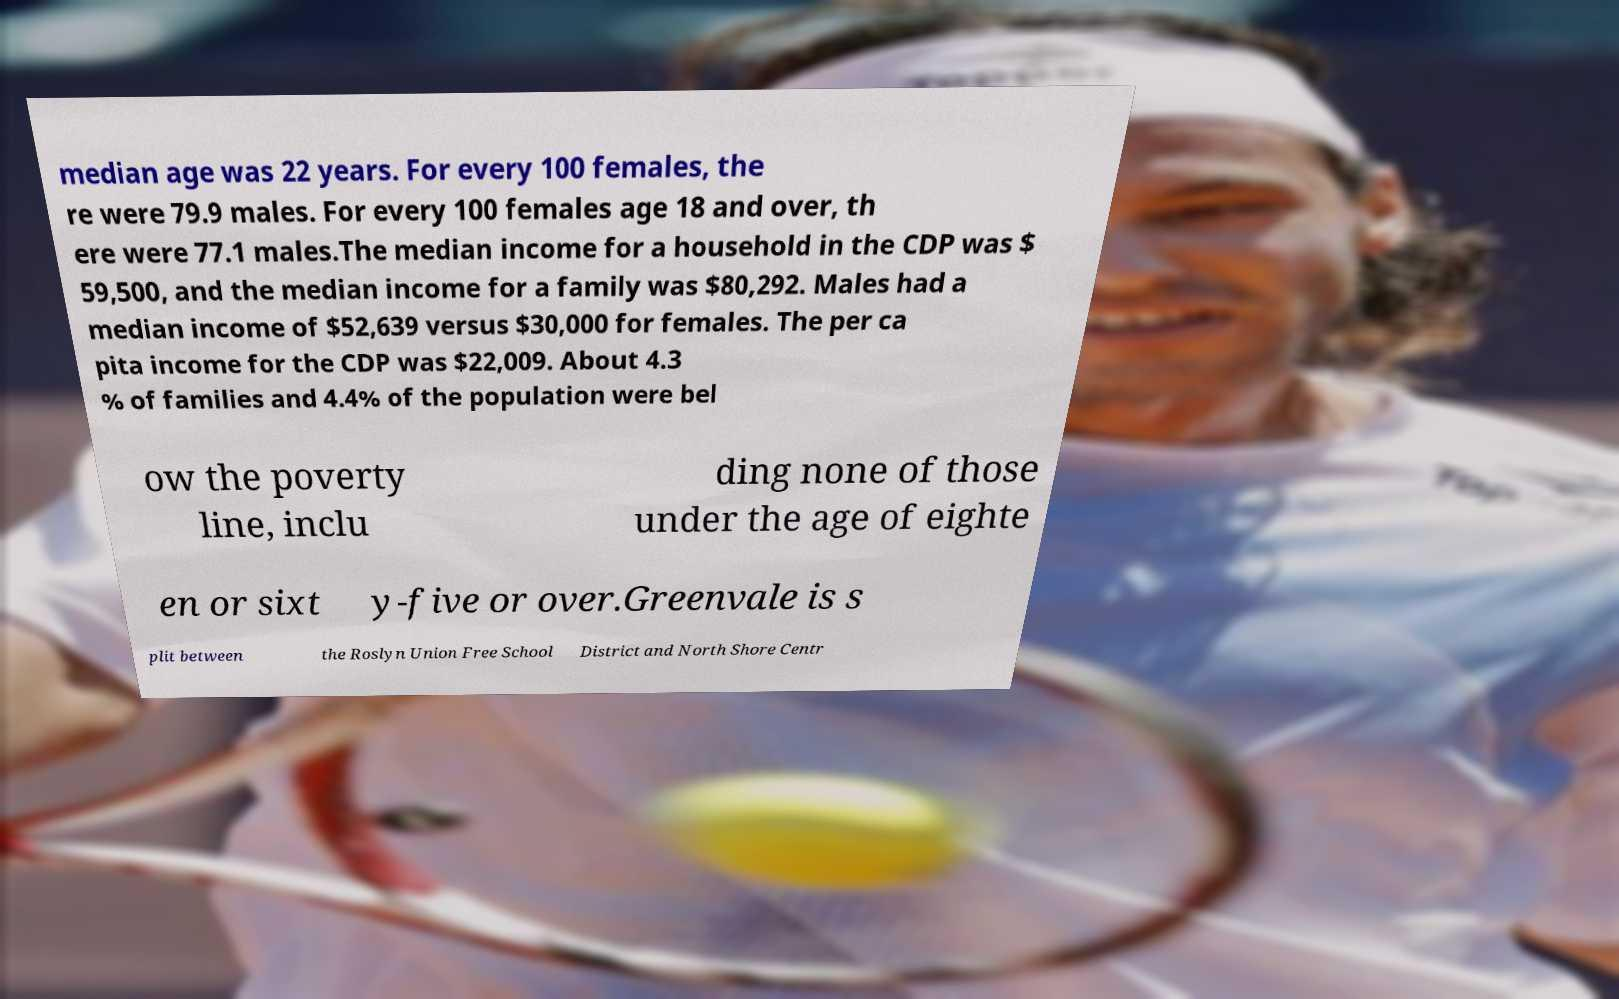Could you extract and type out the text from this image? median age was 22 years. For every 100 females, the re were 79.9 males. For every 100 females age 18 and over, th ere were 77.1 males.The median income for a household in the CDP was $ 59,500, and the median income for a family was $80,292. Males had a median income of $52,639 versus $30,000 for females. The per ca pita income for the CDP was $22,009. About 4.3 % of families and 4.4% of the population were bel ow the poverty line, inclu ding none of those under the age of eighte en or sixt y-five or over.Greenvale is s plit between the Roslyn Union Free School District and North Shore Centr 